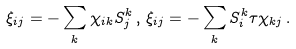<formula> <loc_0><loc_0><loc_500><loc_500>\xi _ { i j } = - \sum _ { k } \chi _ { i k } S ^ { k } _ { j } \, , \, \xi _ { i j } = - \sum _ { k } S ^ { k } _ { i } \tau \chi _ { k j } \, .</formula> 